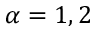Convert formula to latex. <formula><loc_0><loc_0><loc_500><loc_500>\alpha = 1 , 2</formula> 